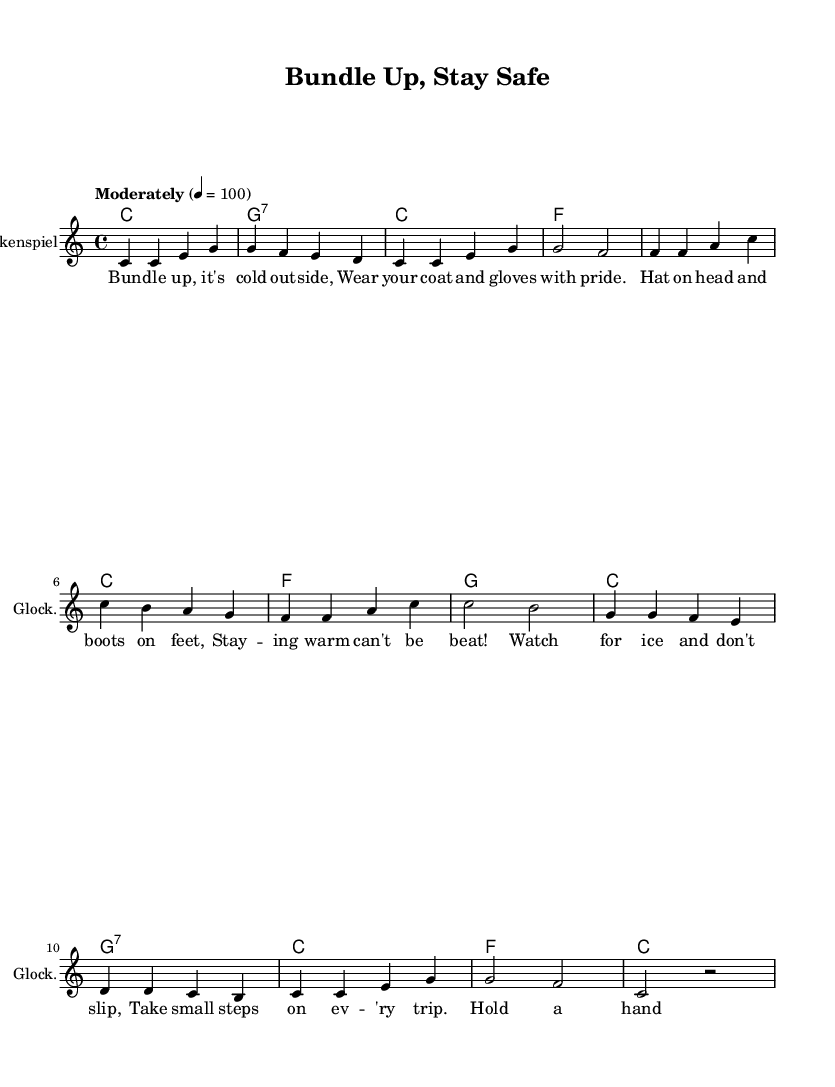What is the key signature of this music? The key signature is presented at the beginning of the staff, indicating that this piece is in C major, which has no sharps or flats.
Answer: C major What is the time signature of this music? The time signature can be found at the beginning of the sheet music, represented as 4/4, meaning there are four beats in each measure and the quarter note gets one beat.
Answer: 4/4 What is the tempo marking for this piece? The tempo marking is indicated in the score above the staff as "Moderately" with a metronome marking of 4 = 100, suggesting a moderate speed where each quarter note equals 100 beats per minute.
Answer: Moderately How many measures does the melody consist of? By counting the grouped sets of four beats (measures) in the melody section, it's noted there are eight measures in total.
Answer: Eight What are the lyrics of the first line in the song? The lyrics are displayed below the melody notes, and the first line reads "Bundle up, it's cold outside," which outlines the opening message of the song.
Answer: Bundle up, it's cold outside What instrument is indicated for the melody? The staff label indicates that the instrument for the melody is the "Glockenspiel," suggesting it is arranged for this specific percussion instrument that plays pitched notes.
Answer: Glockenspiel Which chord appears at the beginning of the music? The first chord is notated at the start of the chord section, identified as a C major chord, marking the harmonic foundation of the piece.
Answer: C major 